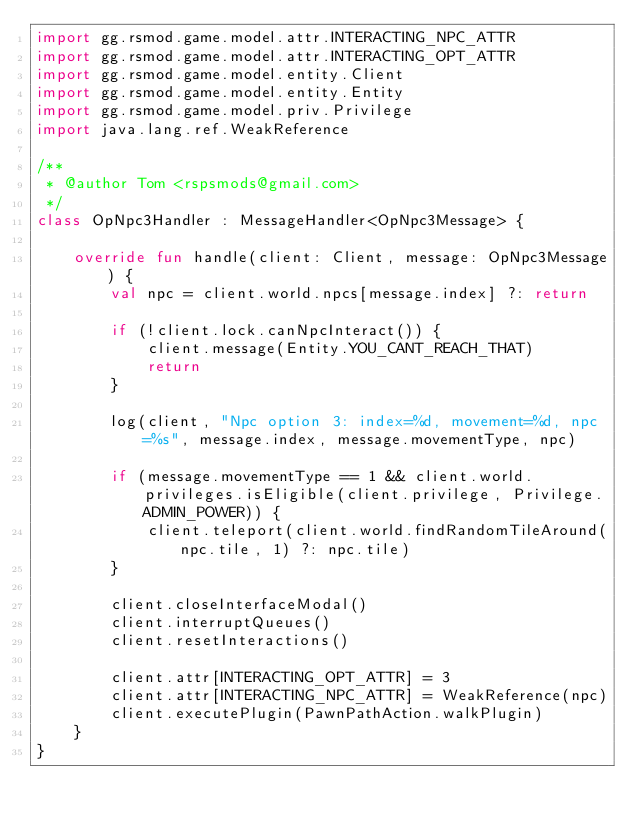Convert code to text. <code><loc_0><loc_0><loc_500><loc_500><_Kotlin_>import gg.rsmod.game.model.attr.INTERACTING_NPC_ATTR
import gg.rsmod.game.model.attr.INTERACTING_OPT_ATTR
import gg.rsmod.game.model.entity.Client
import gg.rsmod.game.model.entity.Entity
import gg.rsmod.game.model.priv.Privilege
import java.lang.ref.WeakReference

/**
 * @author Tom <rspsmods@gmail.com>
 */
class OpNpc3Handler : MessageHandler<OpNpc3Message> {

    override fun handle(client: Client, message: OpNpc3Message) {
        val npc = client.world.npcs[message.index] ?: return

        if (!client.lock.canNpcInteract()) {
            client.message(Entity.YOU_CANT_REACH_THAT)
            return
        }

        log(client, "Npc option 3: index=%d, movement=%d, npc=%s", message.index, message.movementType, npc)

        if (message.movementType == 1 && client.world.privileges.isEligible(client.privilege, Privilege.ADMIN_POWER)) {
            client.teleport(client.world.findRandomTileAround(npc.tile, 1) ?: npc.tile)
        }

        client.closeInterfaceModal()
        client.interruptQueues()
        client.resetInteractions()

        client.attr[INTERACTING_OPT_ATTR] = 3
        client.attr[INTERACTING_NPC_ATTR] = WeakReference(npc)
        client.executePlugin(PawnPathAction.walkPlugin)
    }
}</code> 